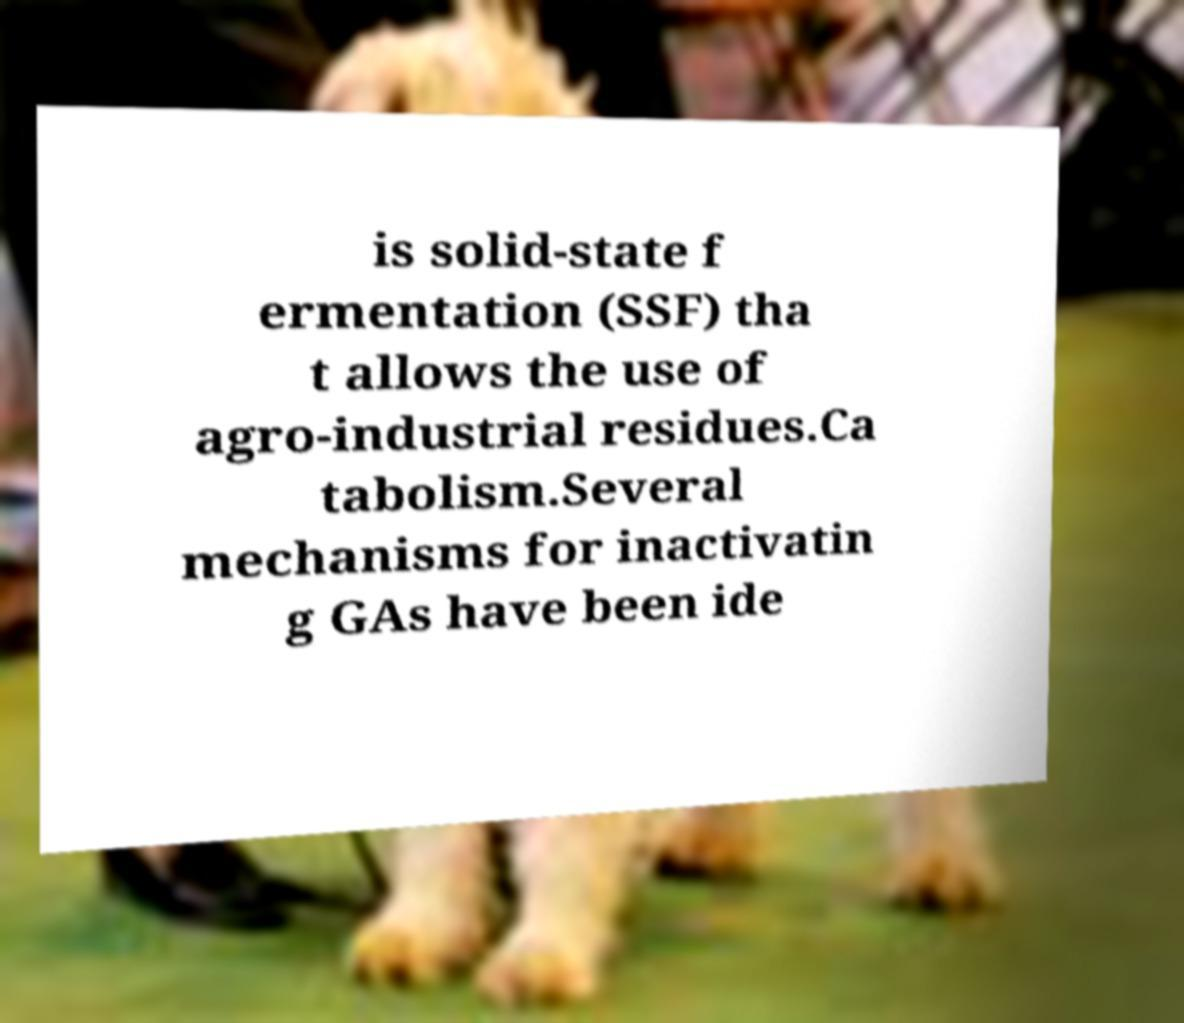Can you read and provide the text displayed in the image?This photo seems to have some interesting text. Can you extract and type it out for me? is solid-state f ermentation (SSF) tha t allows the use of agro-industrial residues.Ca tabolism.Several mechanisms for inactivatin g GAs have been ide 